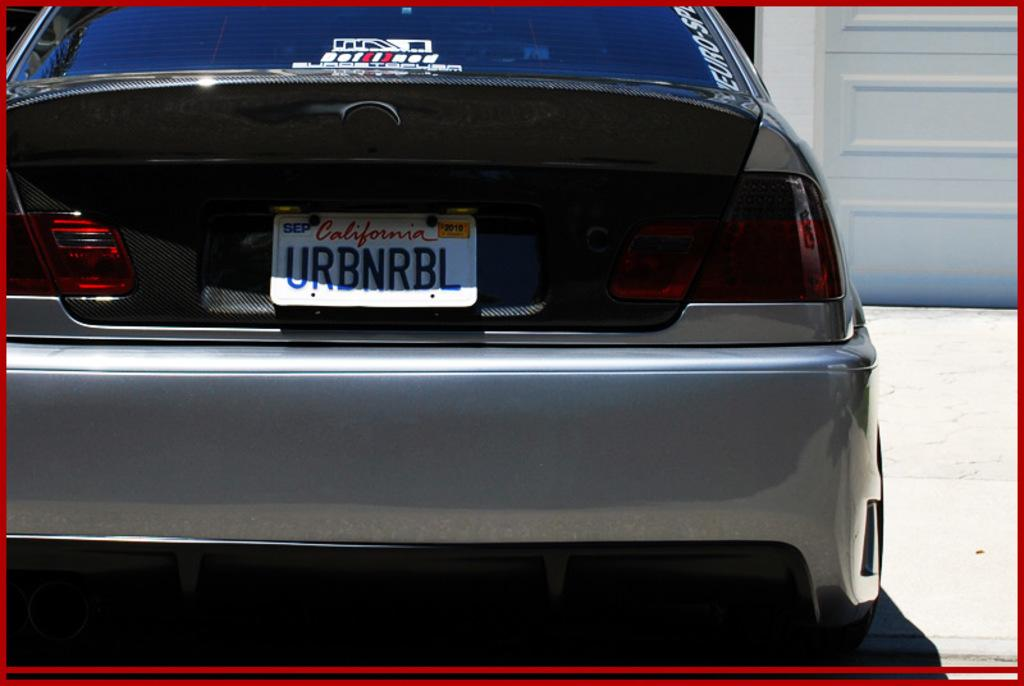Provide a one-sentence caption for the provided image. A light gray sports car with a licence plate from California. 